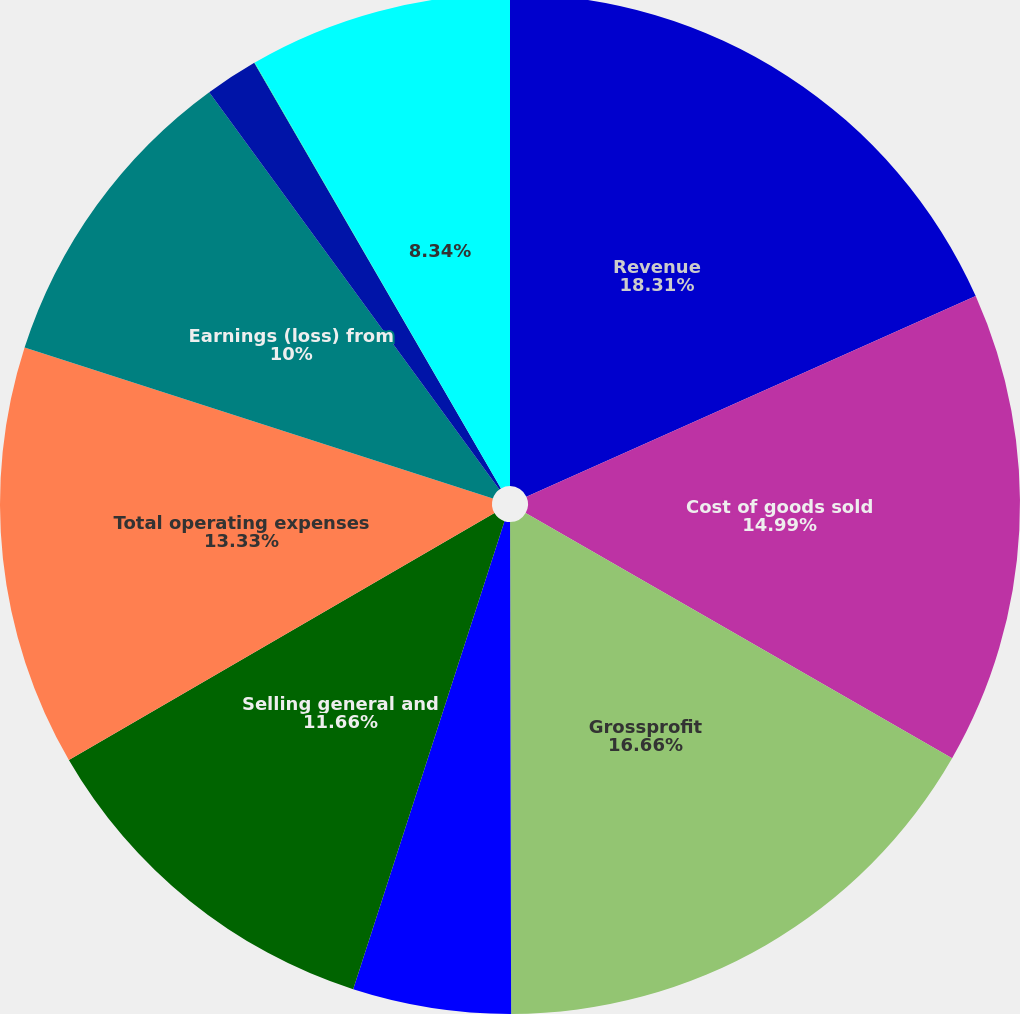Convert chart to OTSL. <chart><loc_0><loc_0><loc_500><loc_500><pie_chart><fcel>Revenue<fcel>Cost of goods sold<fcel>Grossprofit<fcel>Research and development<fcel>Selling general and<fcel>Total operating expenses<fcel>Earnings (loss) from<fcel>Interest expense<fcel>Other(income)net<fcel>Unnamed: 9<nl><fcel>18.32%<fcel>14.99%<fcel>16.66%<fcel>5.01%<fcel>11.66%<fcel>13.33%<fcel>10.0%<fcel>1.68%<fcel>0.02%<fcel>8.34%<nl></chart> 